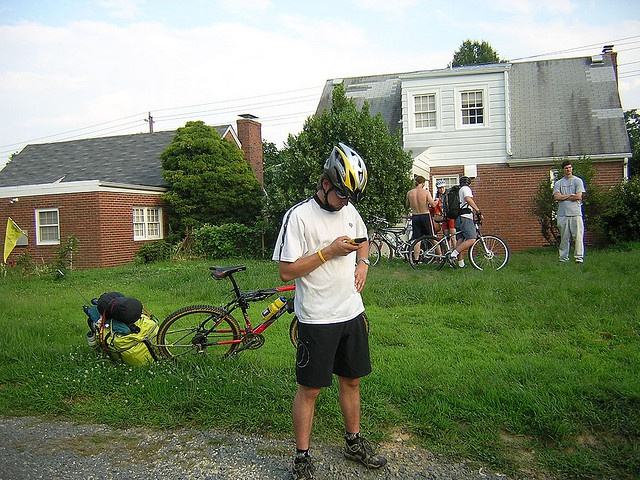Describe the objects in this image and their specific colors. I can see people in lightblue, black, lightgray, olive, and gray tones, bicycle in lightblue, black, darkgreen, green, and gray tones, bicycle in lightblue, black, gray, and darkgreen tones, people in lightblue, darkgray, gray, lightgray, and black tones, and people in lightblue, black, gray, and lightgray tones in this image. 